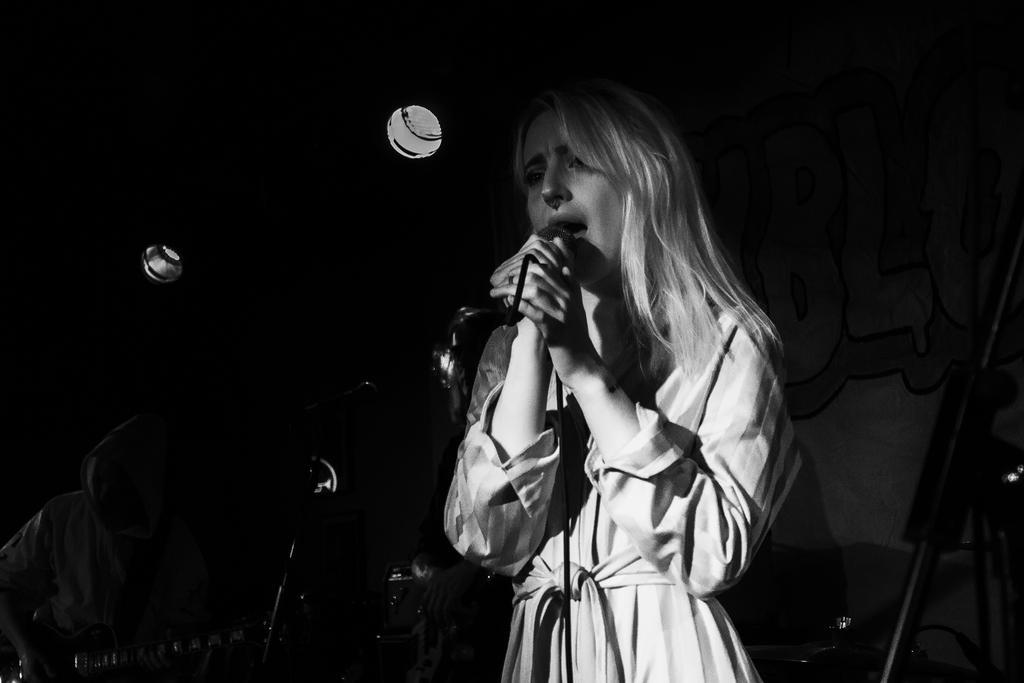In one or two sentences, can you explain what this image depicts? This is a black and white image. This image might be clicked in a musical concert. There are lights on the top and there is a person in the middle who is holding the mic. And there is also a person who is playing guitar in the bottom left corner. 